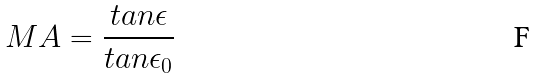Convert formula to latex. <formula><loc_0><loc_0><loc_500><loc_500>M A = \frac { t a n \epsilon } { t a n \epsilon _ { 0 } }</formula> 